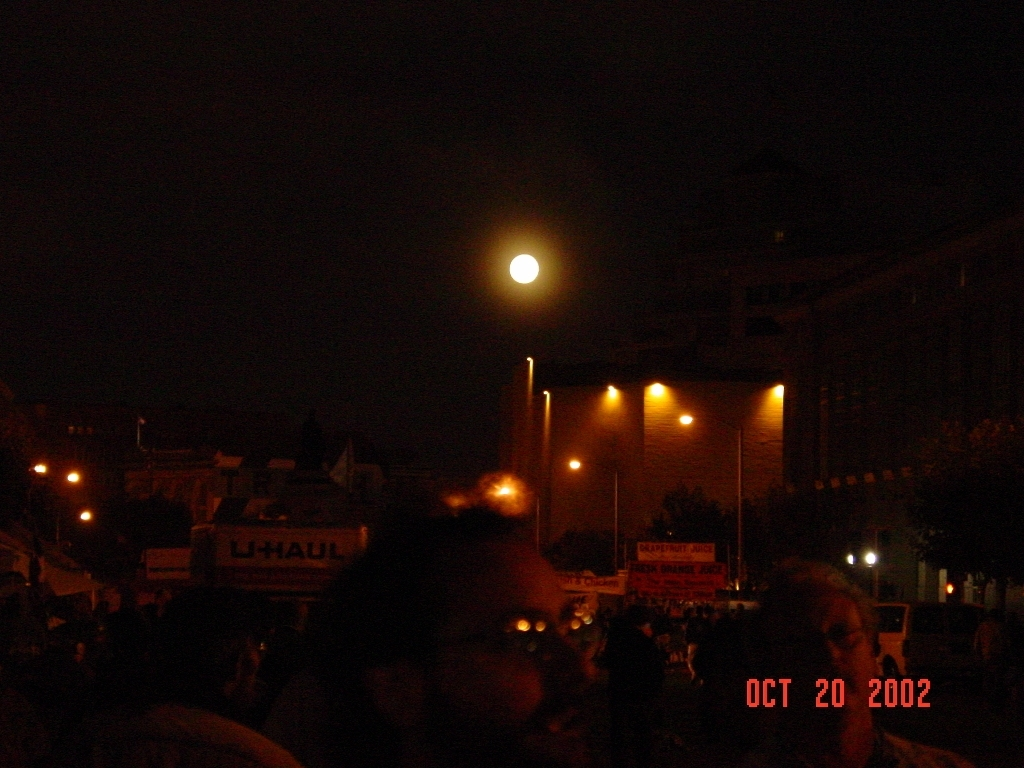Is there a loss of street details in the image?
A. Yes
B. No
Answer with the option's letter from the given choices directly.
 A. 